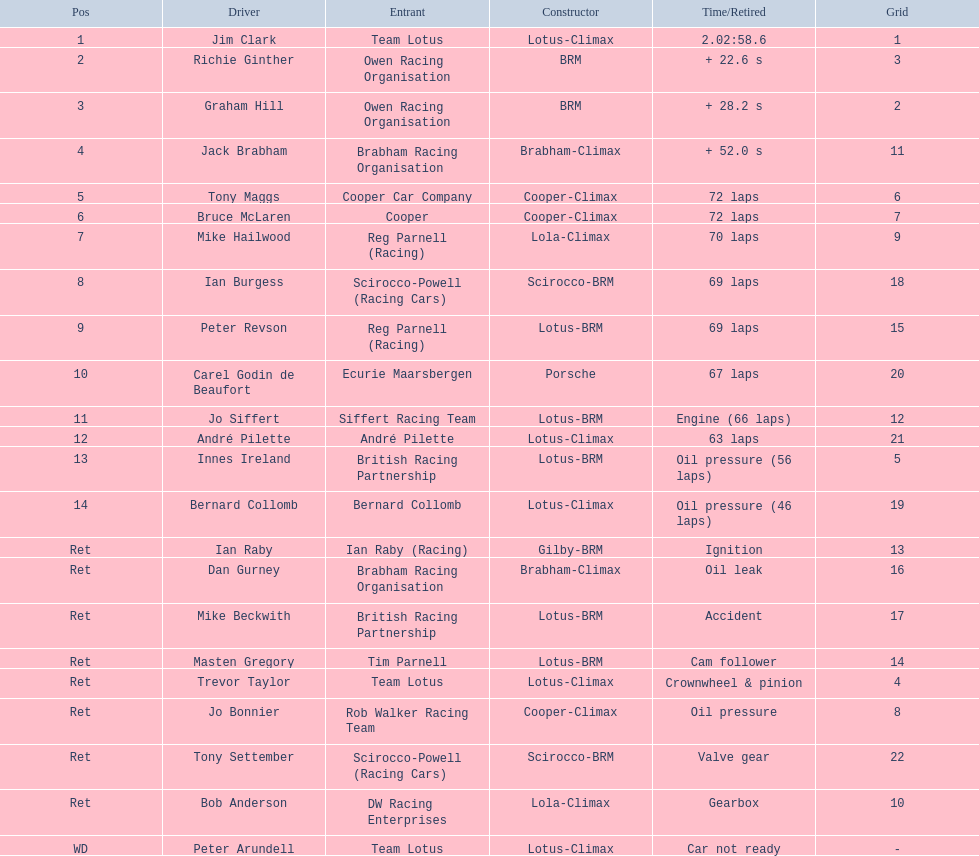Who are all the drivers? Jim Clark, Richie Ginther, Graham Hill, Jack Brabham, Tony Maggs, Bruce McLaren, Mike Hailwood, Ian Burgess, Peter Revson, Carel Godin de Beaufort, Jo Siffert, André Pilette, Innes Ireland, Bernard Collomb, Ian Raby, Dan Gurney, Mike Beckwith, Masten Gregory, Trevor Taylor, Jo Bonnier, Tony Settember, Bob Anderson, Peter Arundell. What were their positions? 1, 2, 3, 4, 5, 6, 7, 8, 9, 10, 11, 12, 13, 14, Ret, Ret, Ret, Ret, Ret, Ret, Ret, Ret, WD. What are all the constructor names? Lotus-Climax, BRM, BRM, Brabham-Climax, Cooper-Climax, Cooper-Climax, Lola-Climax, Scirocco-BRM, Lotus-BRM, Porsche, Lotus-BRM, Lotus-Climax, Lotus-BRM, Lotus-Climax, Gilby-BRM, Brabham-Climax, Lotus-BRM, Lotus-BRM, Lotus-Climax, Cooper-Climax, Scirocco-BRM, Lola-Climax, Lotus-Climax. And which drivers drove a cooper-climax? Tony Maggs, Bruce McLaren. Between those tow, who was positioned higher? Tony Maggs. 